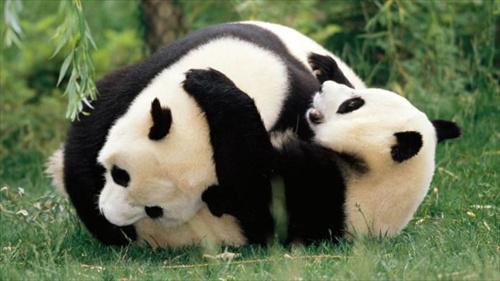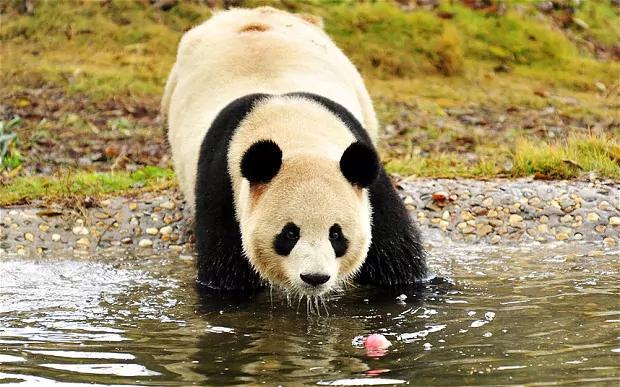The first image is the image on the left, the second image is the image on the right. Given the left and right images, does the statement "There are two different animal species in the right image." hold true? Answer yes or no. No. The first image is the image on the left, the second image is the image on the right. Evaluate the accuracy of this statement regarding the images: "In one image, a standing panda figure on the right is looking down toward another panda, and in the other image, the mouth of a panda with its body turned leftward and its face forward is next to leafy foliage.". Is it true? Answer yes or no. No. 